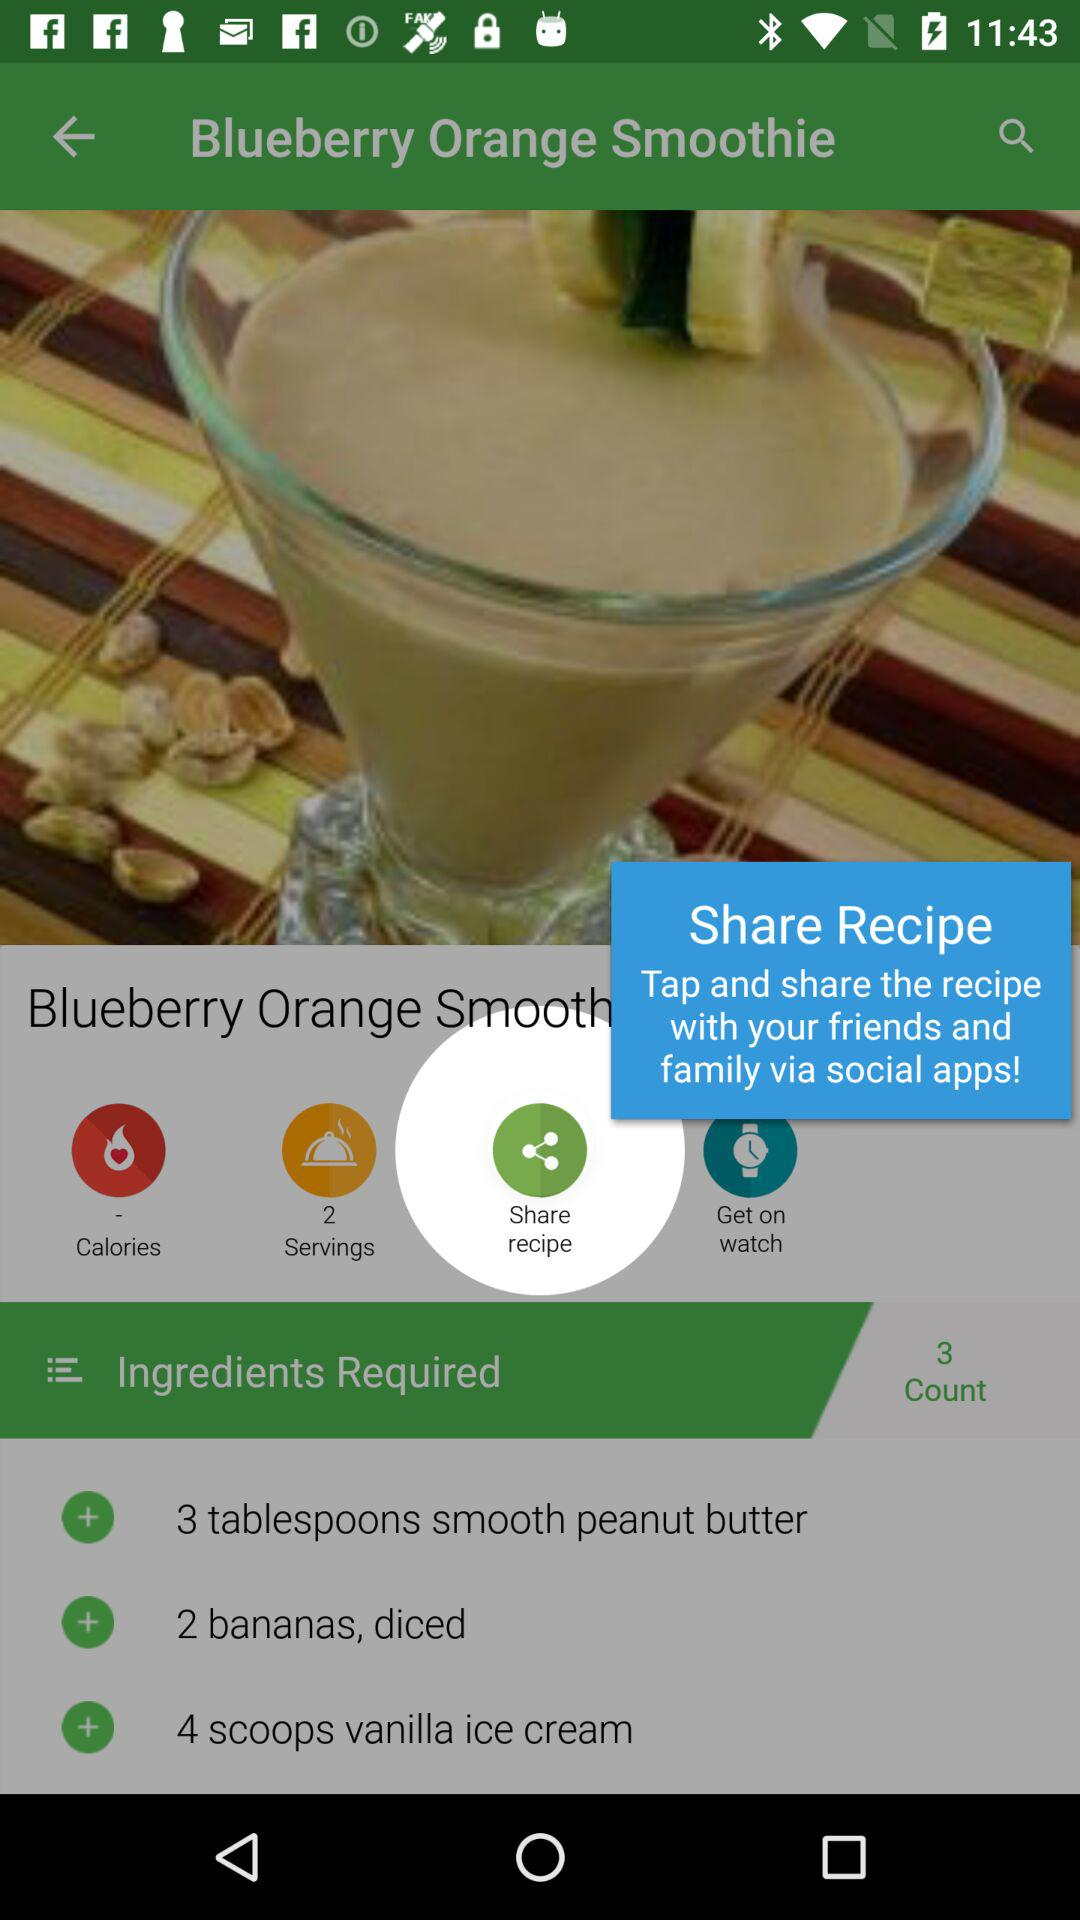How many more tablespoons of smooth peanut butter are needed than banana slices?
Answer the question using a single word or phrase. 1 